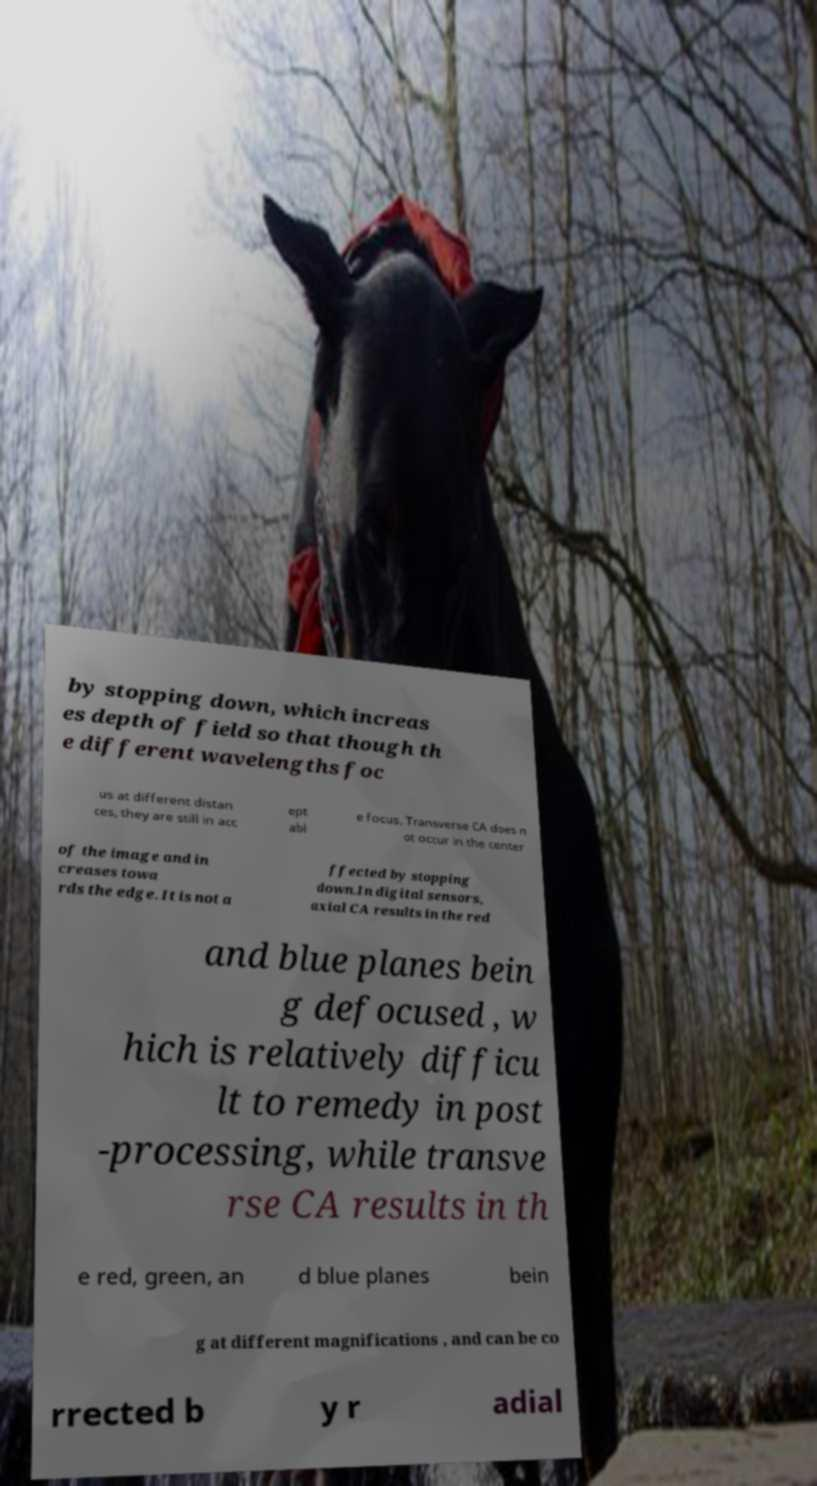What messages or text are displayed in this image? I need them in a readable, typed format. by stopping down, which increas es depth of field so that though th e different wavelengths foc us at different distan ces, they are still in acc ept abl e focus. Transverse CA does n ot occur in the center of the image and in creases towa rds the edge. It is not a ffected by stopping down.In digital sensors, axial CA results in the red and blue planes bein g defocused , w hich is relatively difficu lt to remedy in post -processing, while transve rse CA results in th e red, green, an d blue planes bein g at different magnifications , and can be co rrected b y r adial 